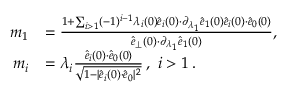<formula> <loc_0><loc_0><loc_500><loc_500>\begin{array} { r l } { \, m _ { 1 } } & { = \frac { 1 + \sum _ { i > 1 } ( - 1 ) ^ { i - 1 } \lambda _ { i } ( 0 ) \hat { e } _ { i } ( 0 ) { \cdot } \partial _ { \lambda _ { 1 } } \hat { e } _ { 1 } ( 0 ) \hat { e } _ { i } ( 0 ) { \cdot } \hat { e } _ { 0 } ( 0 ) } { \hat { e } _ { \perp } ( 0 ) { \cdot } \partial _ { \lambda _ { 1 } } \hat { e } _ { 1 } ( 0 ) } , } \\ { \, m _ { i } } & { = \lambda _ { i } \frac { \hat { e } _ { i } ( 0 ) { \cdot } \hat { e } _ { 0 } ( 0 ) } { \sqrt { 1 - | \hat { e } _ { i } ( 0 ) { \cdot } \hat { e } _ { 0 } | ^ { 2 } } } \, , i > 1 \, . } \end{array}</formula> 